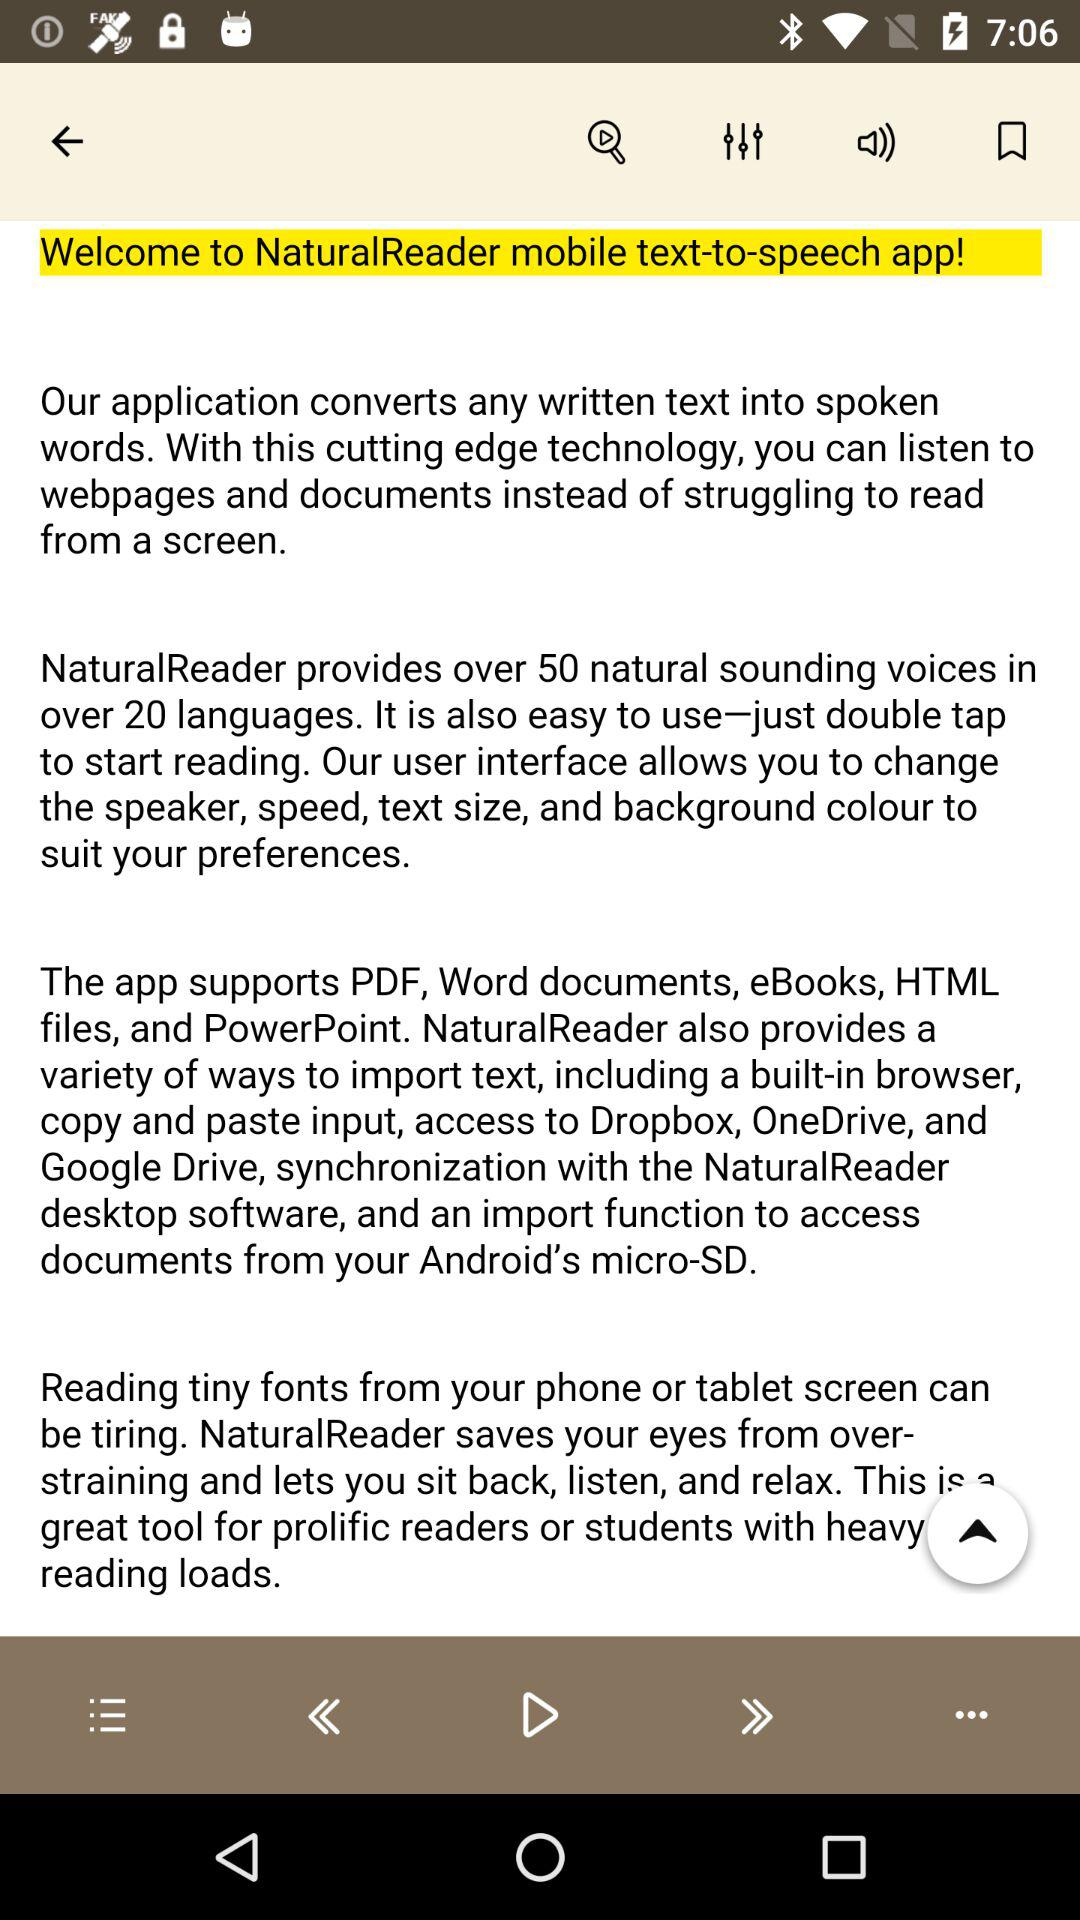How many natural sounding voices and languages does "NaturalReader" provide? "NaturalReader" provides over 50 natural sounding voices and over 20 languages. 